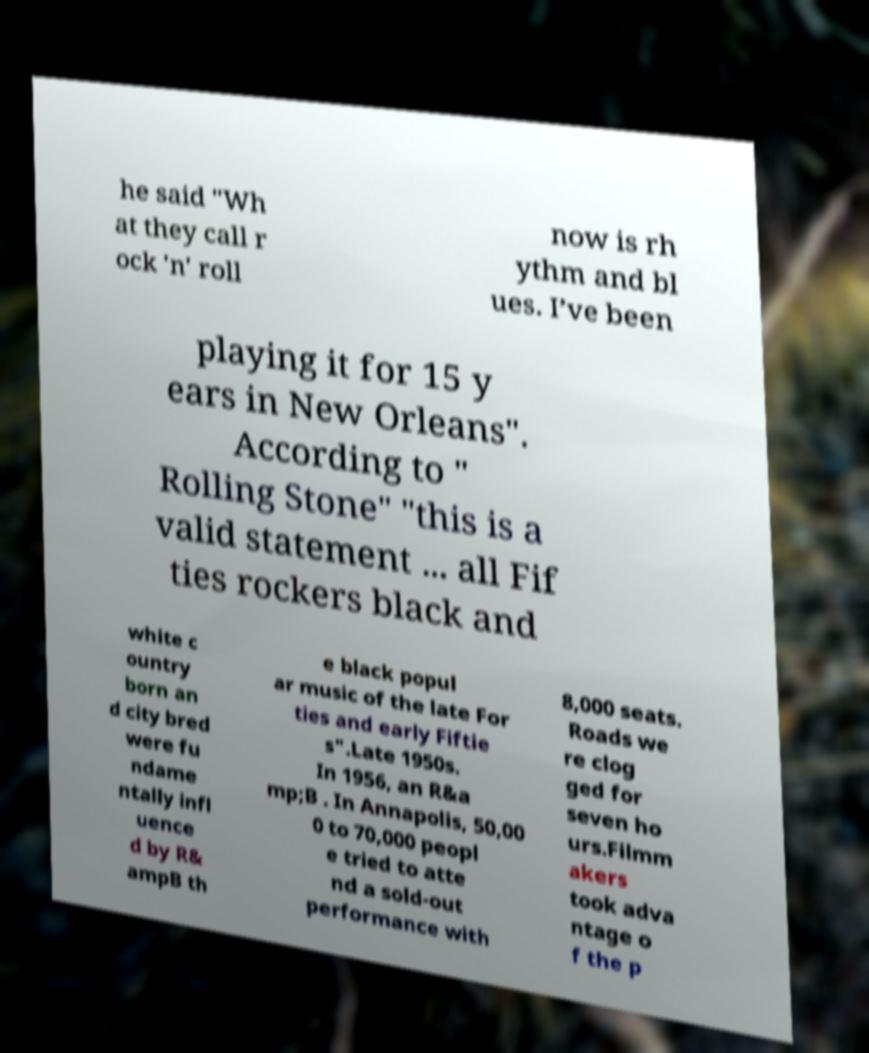Could you extract and type out the text from this image? he said "Wh at they call r ock 'n' roll now is rh ythm and bl ues. I’ve been playing it for 15 y ears in New Orleans". According to " Rolling Stone" "this is a valid statement ... all Fif ties rockers black and white c ountry born an d city bred were fu ndame ntally infl uence d by R& ampB th e black popul ar music of the late For ties and early Fiftie s".Late 1950s. In 1956, an R&a mp;B . In Annapolis, 50,00 0 to 70,000 peopl e tried to atte nd a sold-out performance with 8,000 seats. Roads we re clog ged for seven ho urs.Filmm akers took adva ntage o f the p 